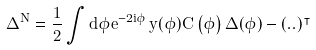Convert formula to latex. <formula><loc_0><loc_0><loc_500><loc_500>\Delta ^ { N } = \frac { 1 } { 2 } \int d \phi e ^ { - 2 i \phi } \, y ( \phi ) C \left ( \phi \right ) \Delta ( \phi ) - ( . . ) ^ { \intercal }</formula> 